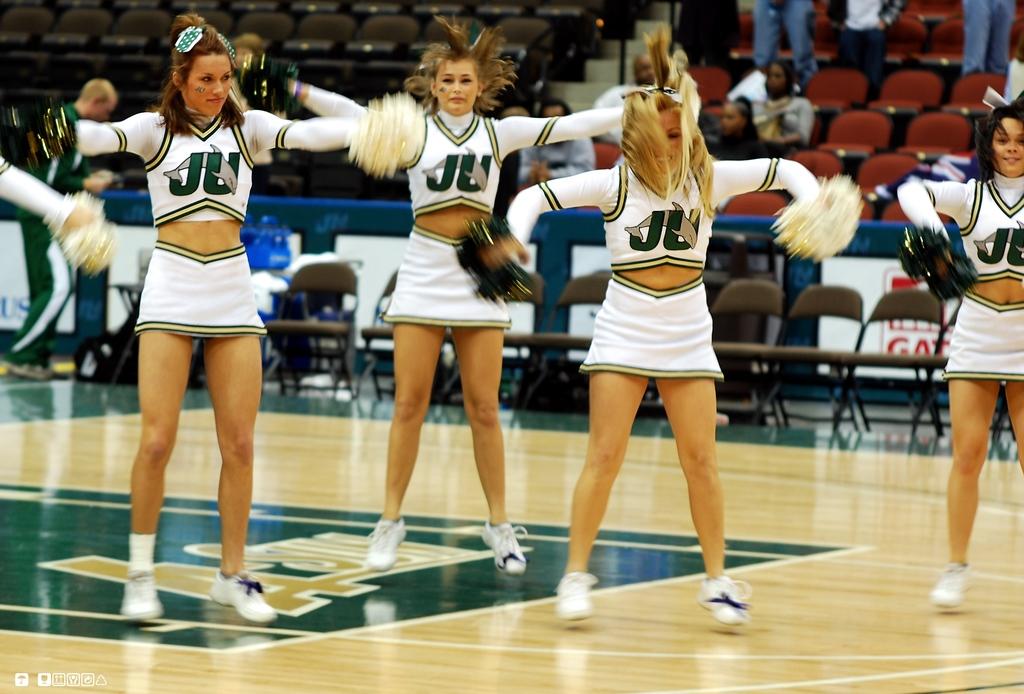What initials are on the cheerleader's uniforms?
Ensure brevity in your answer.  Ju. 